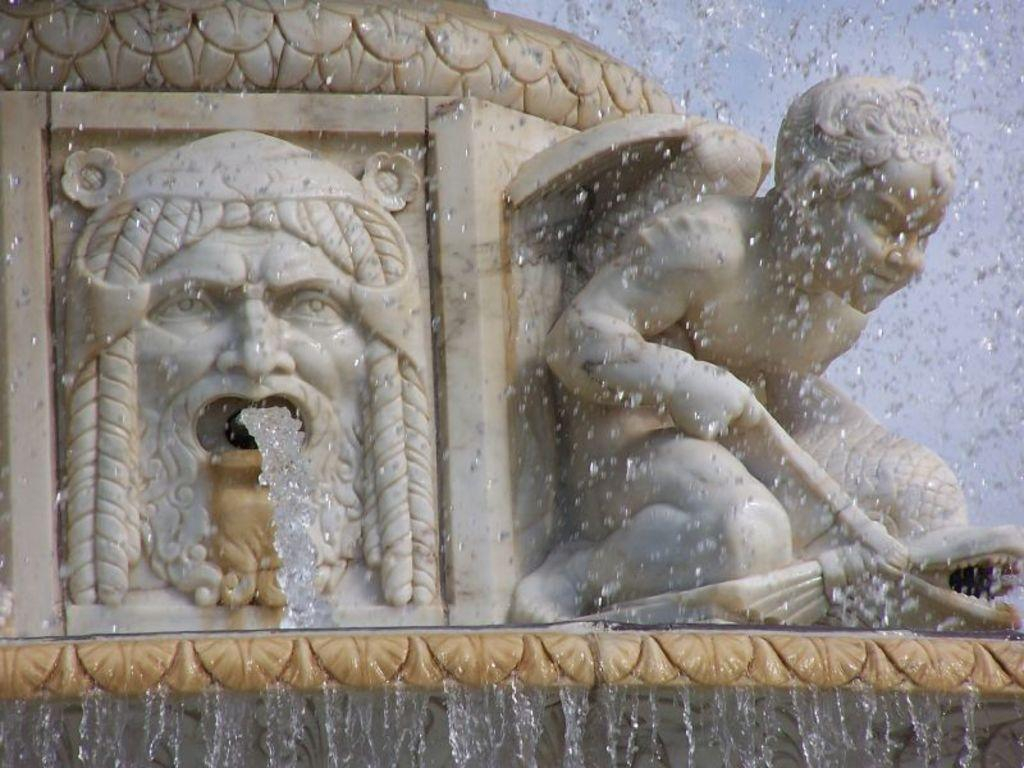What can be seen in the image that is not a natural object? There are sculptures in the image. What are the sculptures doing in the image? The sculptures are releasing water. What type of knife can be seen in the image? There is no knife present in the image. What time does the clock show in the image? There is no clock present in the image. How many snakes can be seen in the image? There are no snakes present in the image. 